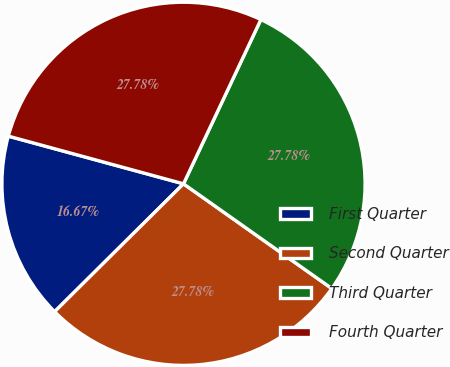Convert chart. <chart><loc_0><loc_0><loc_500><loc_500><pie_chart><fcel>First Quarter<fcel>Second Quarter<fcel>Third Quarter<fcel>Fourth Quarter<nl><fcel>16.67%<fcel>27.78%<fcel>27.78%<fcel>27.78%<nl></chart> 